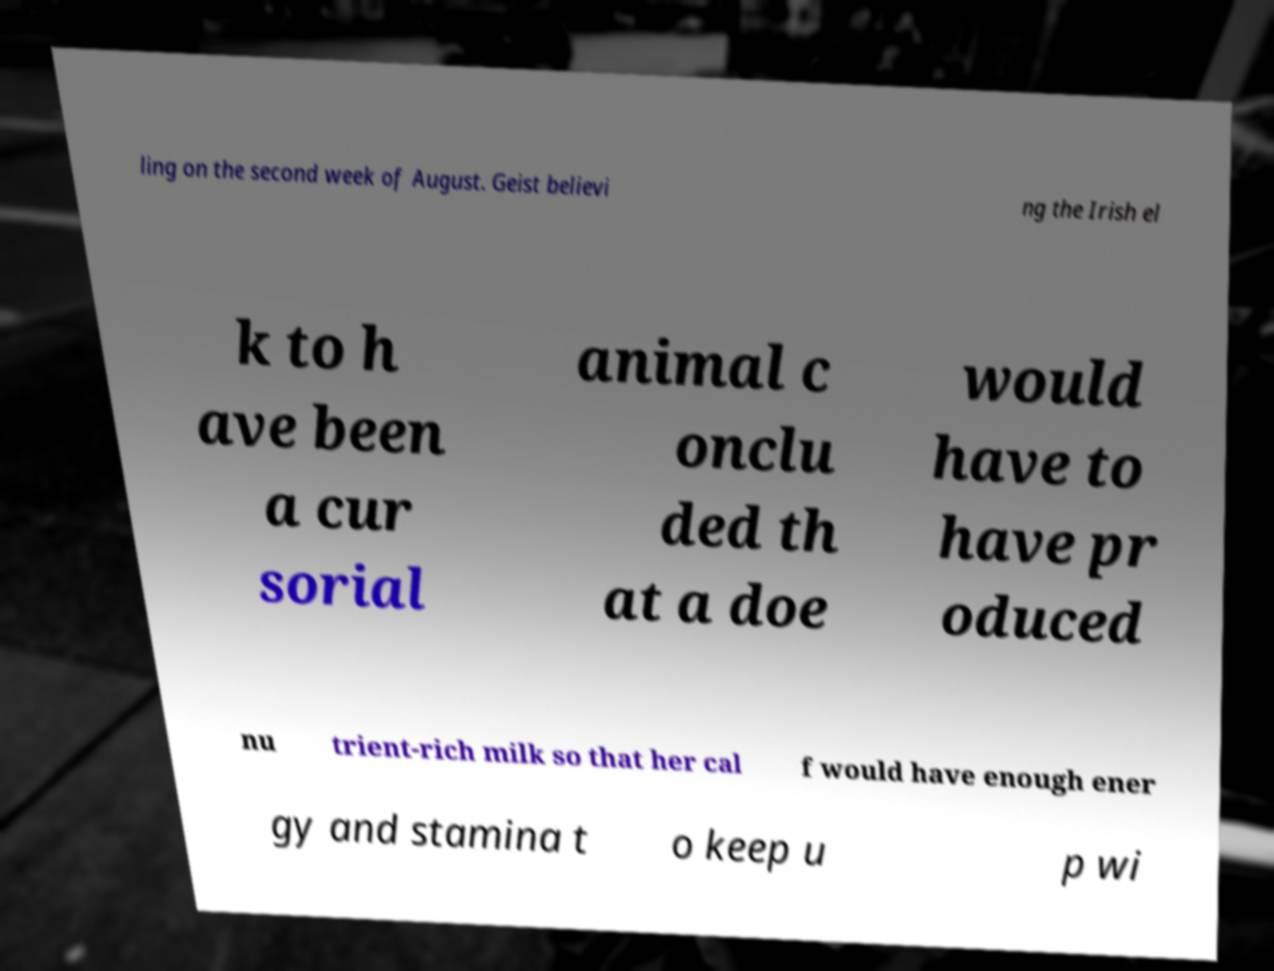For documentation purposes, I need the text within this image transcribed. Could you provide that? ling on the second week of August. Geist believi ng the Irish el k to h ave been a cur sorial animal c onclu ded th at a doe would have to have pr oduced nu trient-rich milk so that her cal f would have enough ener gy and stamina t o keep u p wi 